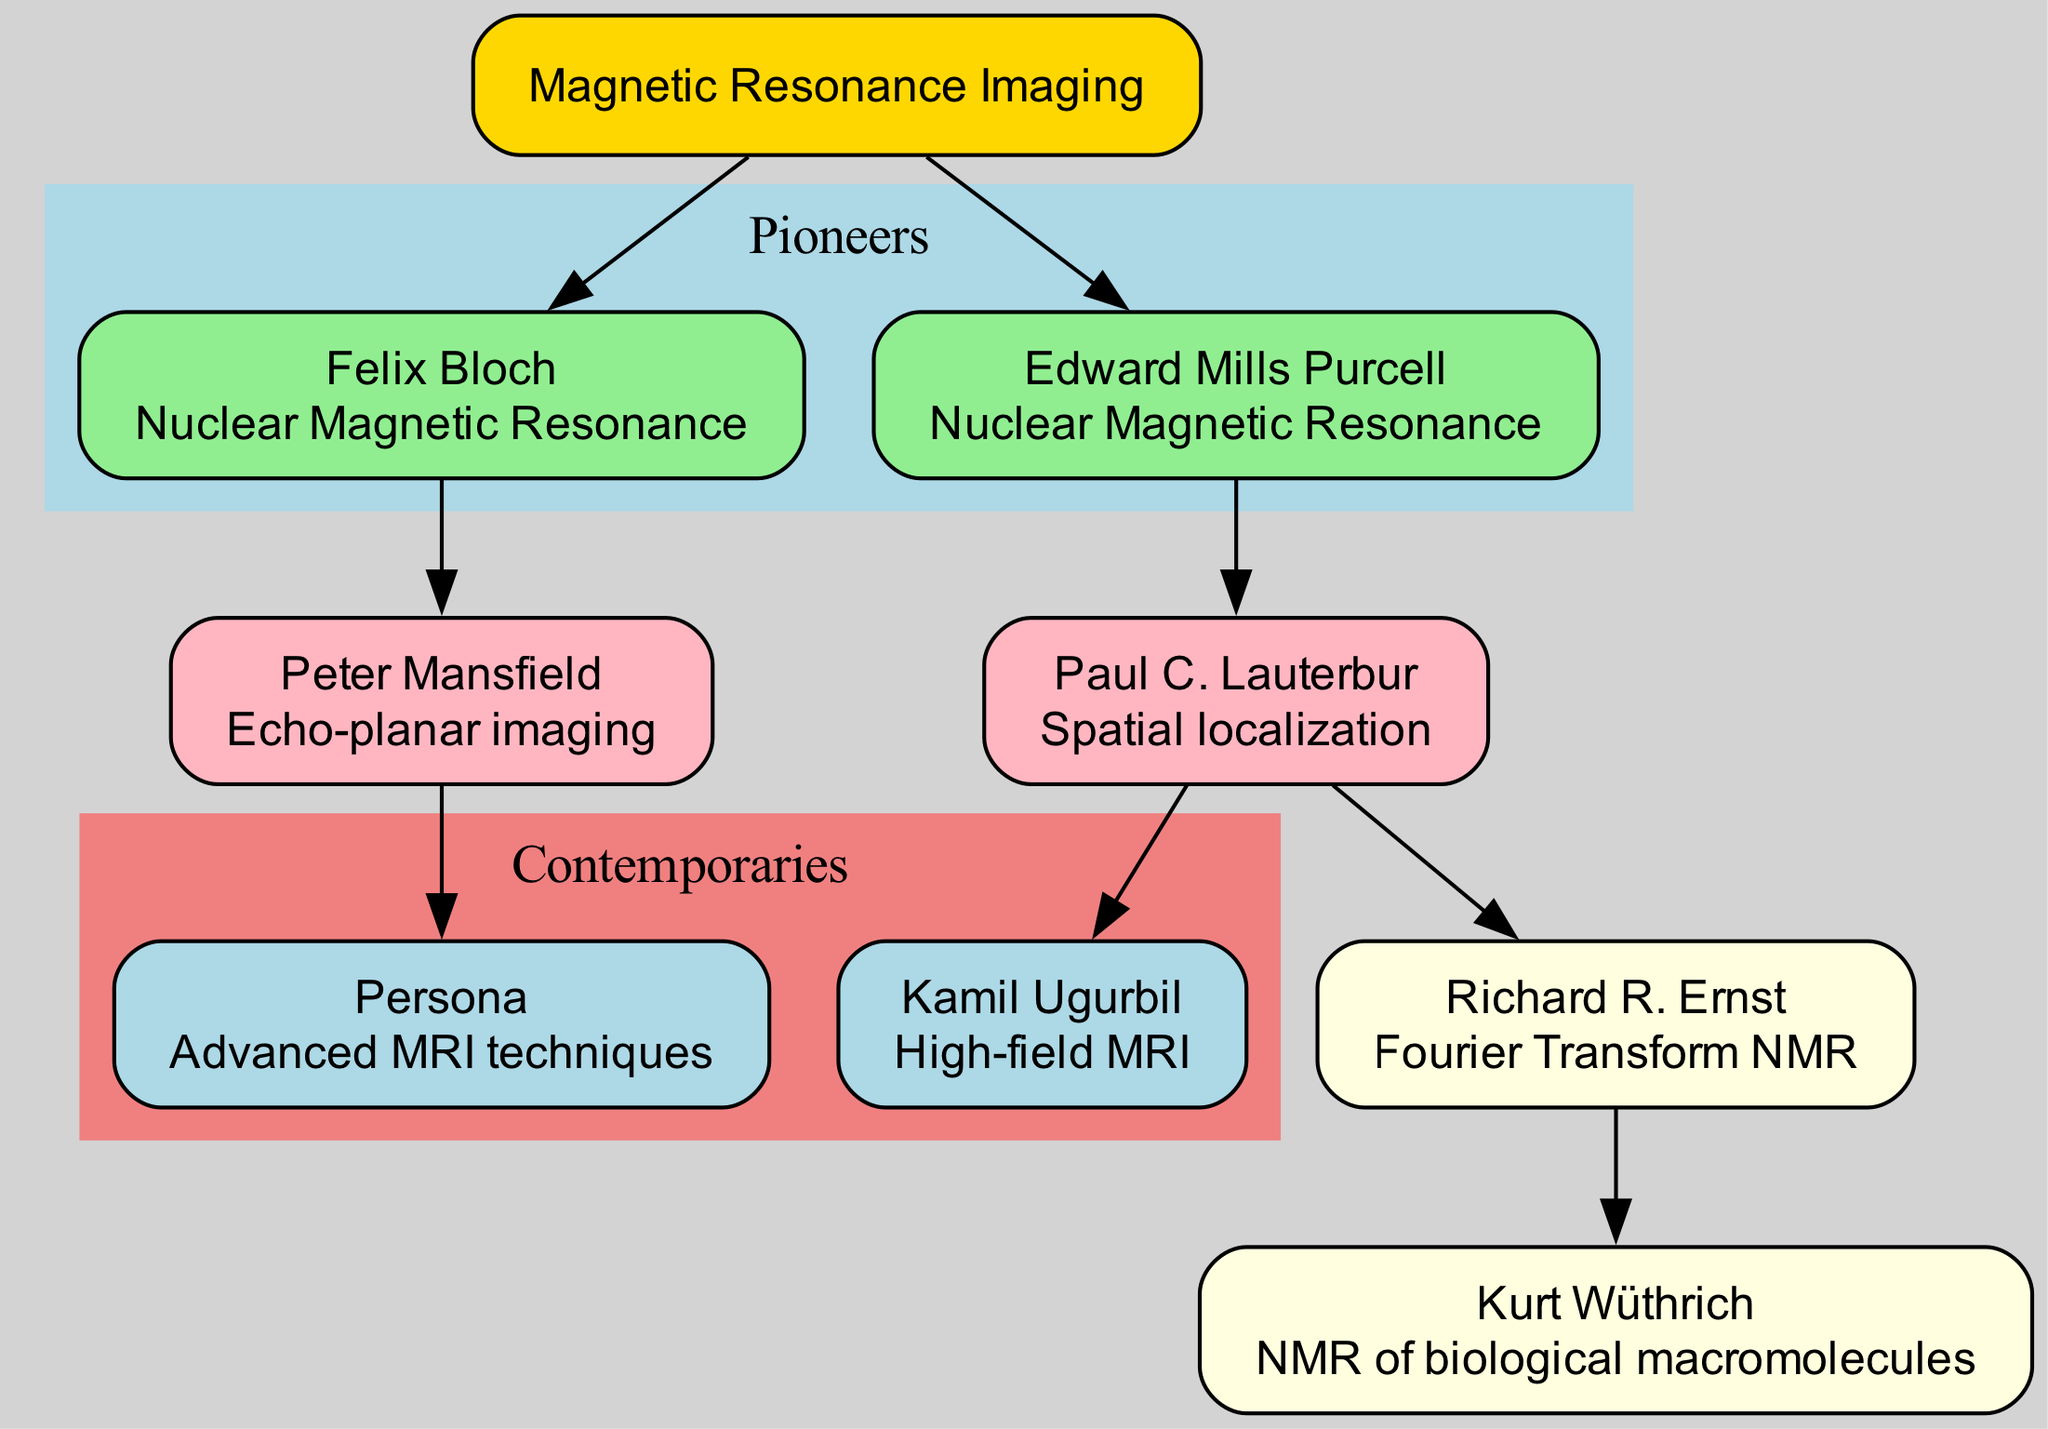What is the root of the family tree? The root node labeled "Magnetic Resonance Imaging" is the starting point of the diagram. It is the central theme that connects all other nodes.
Answer: Magnetic Resonance Imaging How many pioneers are represented in the diagram? The pioneers section contains two individuals: Felix Bloch and Edward Mills Purcell. Therefore, the count of pioneer nodes is two.
Answer: 2 Who contributed to spatial localization? The node that describes the contribution of spatial localization is linked to Paul C. Lauterbur, who is the corresponding scientist in the second generation.
Answer: Paul C. Lauterbur Which scientist has Richard R. Ernst as a mentor? Richard R. Ernst is a third-generation scientist who specifies Paul C. Lauterbur as his mentor. The relationship highlights the mentorship lineage in the diagram.
Answer: Paul C. Lauterbur What is the contribution of Persona in the contemporaries section? Persona, listed in the contemporaries section, has made contributions to advanced MRI techniques. This information is presented directly on the corresponding node.
Answer: Advanced MRI techniques Which pioneer is associated with Peter Mansfield? Peter Mansfield is linked as a second-generation scientist whose mentor is Felix Bloch according to the diagram structure. However, the question asks specifically about the connection to Peter Mansfield. Since Persona is a contemporary that lists Peter Mansfield as a mentor, the relationship here shows a direct mentorship from the previous generation.
Answer: Felix Bloch Which scientist is known for echo-planar imaging? Peter Mansfield's contribution is detailed as echo-planar imaging, making him the scientist known for this specific advancement in MRI technology.
Answer: Peter Mansfield Which second-generation scientist's mentor is Felix Bloch? Among the second-generation scientists, the one whose mentor is Felix Bloch is Peter Mansfield. This links the second-generation contributions back to the pioneers.
Answer: Peter Mansfield Which generation does Kurt Wüthrich belong to? The node labeled as Kurt Wüthrich indicates that he is part of the third generation in the lineage of influential scientists. This is determined by the section and the connections leading back to his mentor.
Answer: Third generation 